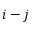<formula> <loc_0><loc_0><loc_500><loc_500>i - j</formula> 